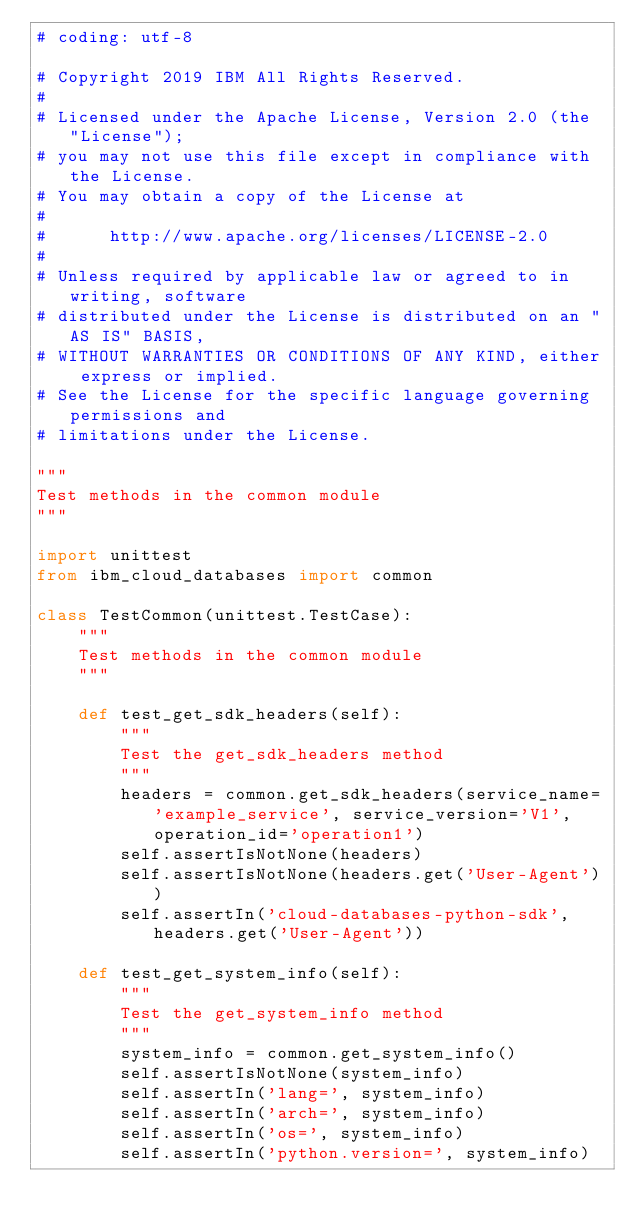<code> <loc_0><loc_0><loc_500><loc_500><_Python_># coding: utf-8

# Copyright 2019 IBM All Rights Reserved.
#
# Licensed under the Apache License, Version 2.0 (the "License");
# you may not use this file except in compliance with the License.
# You may obtain a copy of the License at
#
#      http://www.apache.org/licenses/LICENSE-2.0
#
# Unless required by applicable law or agreed to in writing, software
# distributed under the License is distributed on an "AS IS" BASIS,
# WITHOUT WARRANTIES OR CONDITIONS OF ANY KIND, either express or implied.
# See the License for the specific language governing permissions and
# limitations under the License.

"""
Test methods in the common module
"""

import unittest
from ibm_cloud_databases import common

class TestCommon(unittest.TestCase):
    """
    Test methods in the common module
    """

    def test_get_sdk_headers(self):
        """
        Test the get_sdk_headers method
        """
        headers = common.get_sdk_headers(service_name='example_service', service_version='V1', operation_id='operation1')
        self.assertIsNotNone(headers)
        self.assertIsNotNone(headers.get('User-Agent'))
        self.assertIn('cloud-databases-python-sdk', headers.get('User-Agent'))

    def test_get_system_info(self):
        """
        Test the get_system_info method
        """
        system_info = common.get_system_info()
        self.assertIsNotNone(system_info)
        self.assertIn('lang=', system_info)
        self.assertIn('arch=', system_info)
        self.assertIn('os=', system_info)
        self.assertIn('python.version=', system_info)
</code> 